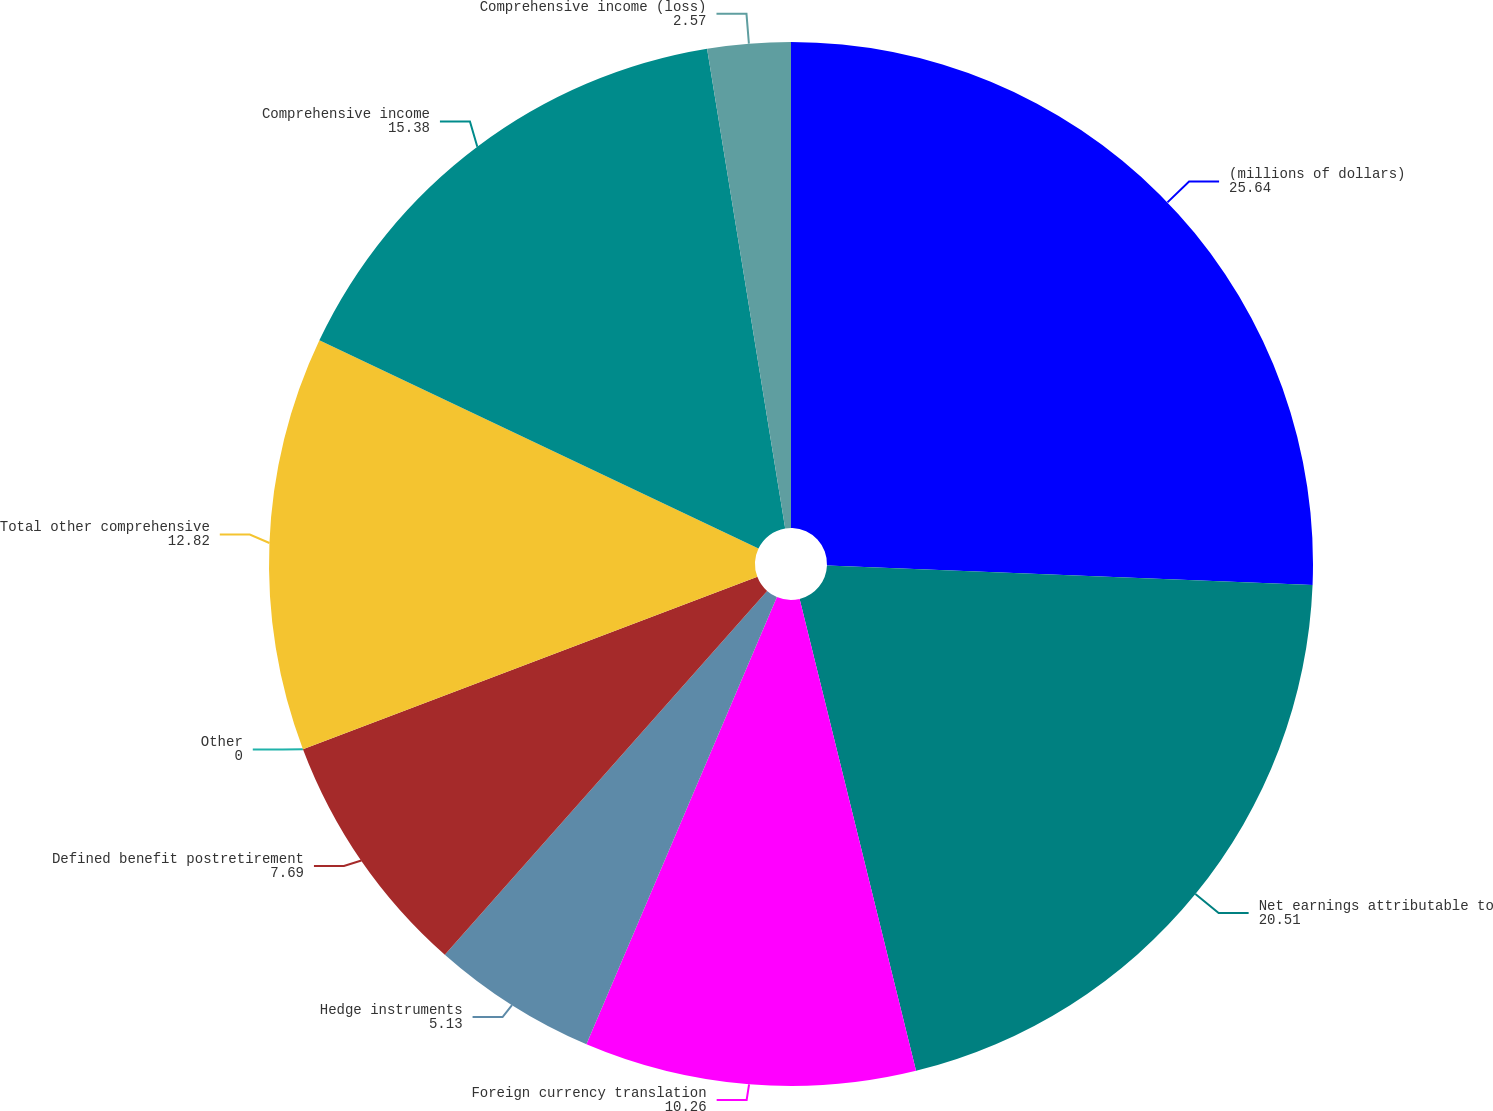Convert chart. <chart><loc_0><loc_0><loc_500><loc_500><pie_chart><fcel>(millions of dollars)<fcel>Net earnings attributable to<fcel>Foreign currency translation<fcel>Hedge instruments<fcel>Defined benefit postretirement<fcel>Other<fcel>Total other comprehensive<fcel>Comprehensive income<fcel>Comprehensive income (loss)<nl><fcel>25.64%<fcel>20.51%<fcel>10.26%<fcel>5.13%<fcel>7.69%<fcel>0.0%<fcel>12.82%<fcel>15.38%<fcel>2.57%<nl></chart> 